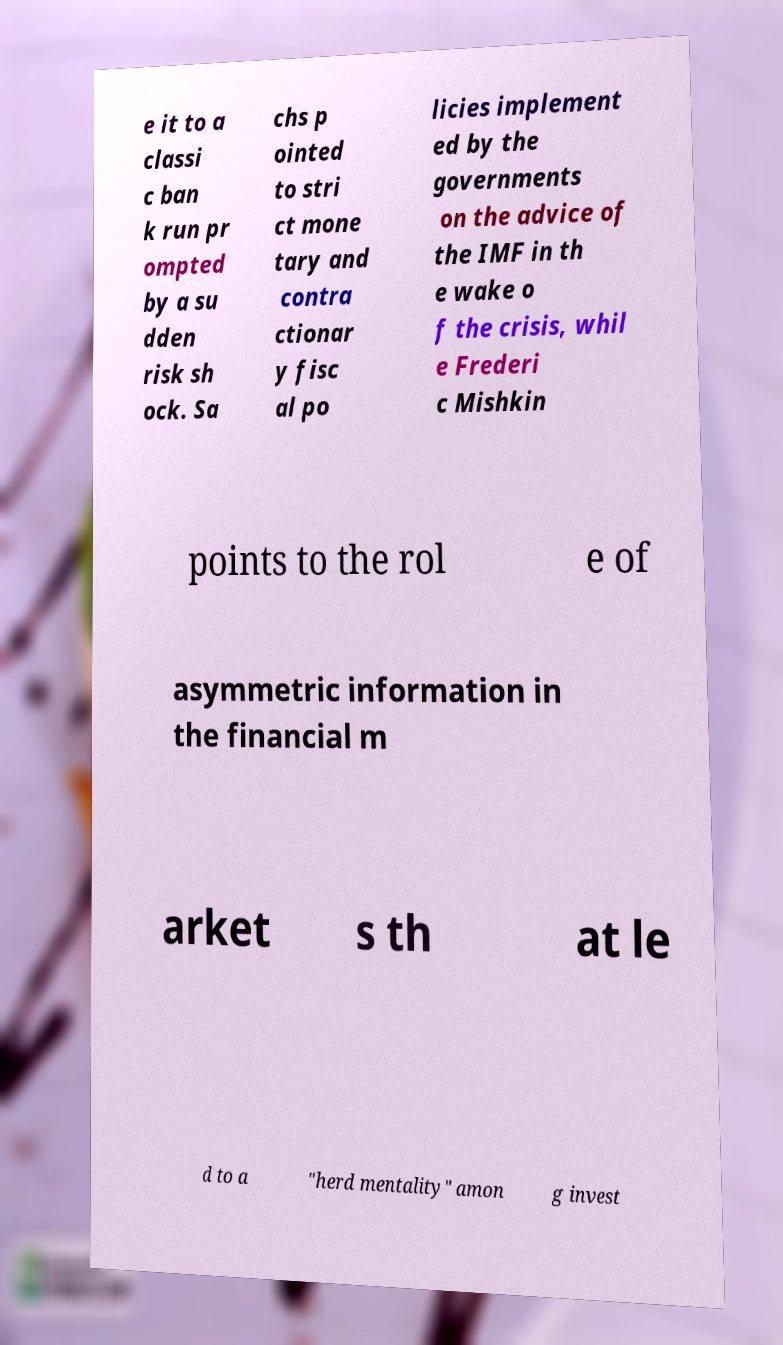Can you accurately transcribe the text from the provided image for me? e it to a classi c ban k run pr ompted by a su dden risk sh ock. Sa chs p ointed to stri ct mone tary and contra ctionar y fisc al po licies implement ed by the governments on the advice of the IMF in th e wake o f the crisis, whil e Frederi c Mishkin points to the rol e of asymmetric information in the financial m arket s th at le d to a "herd mentality" amon g invest 